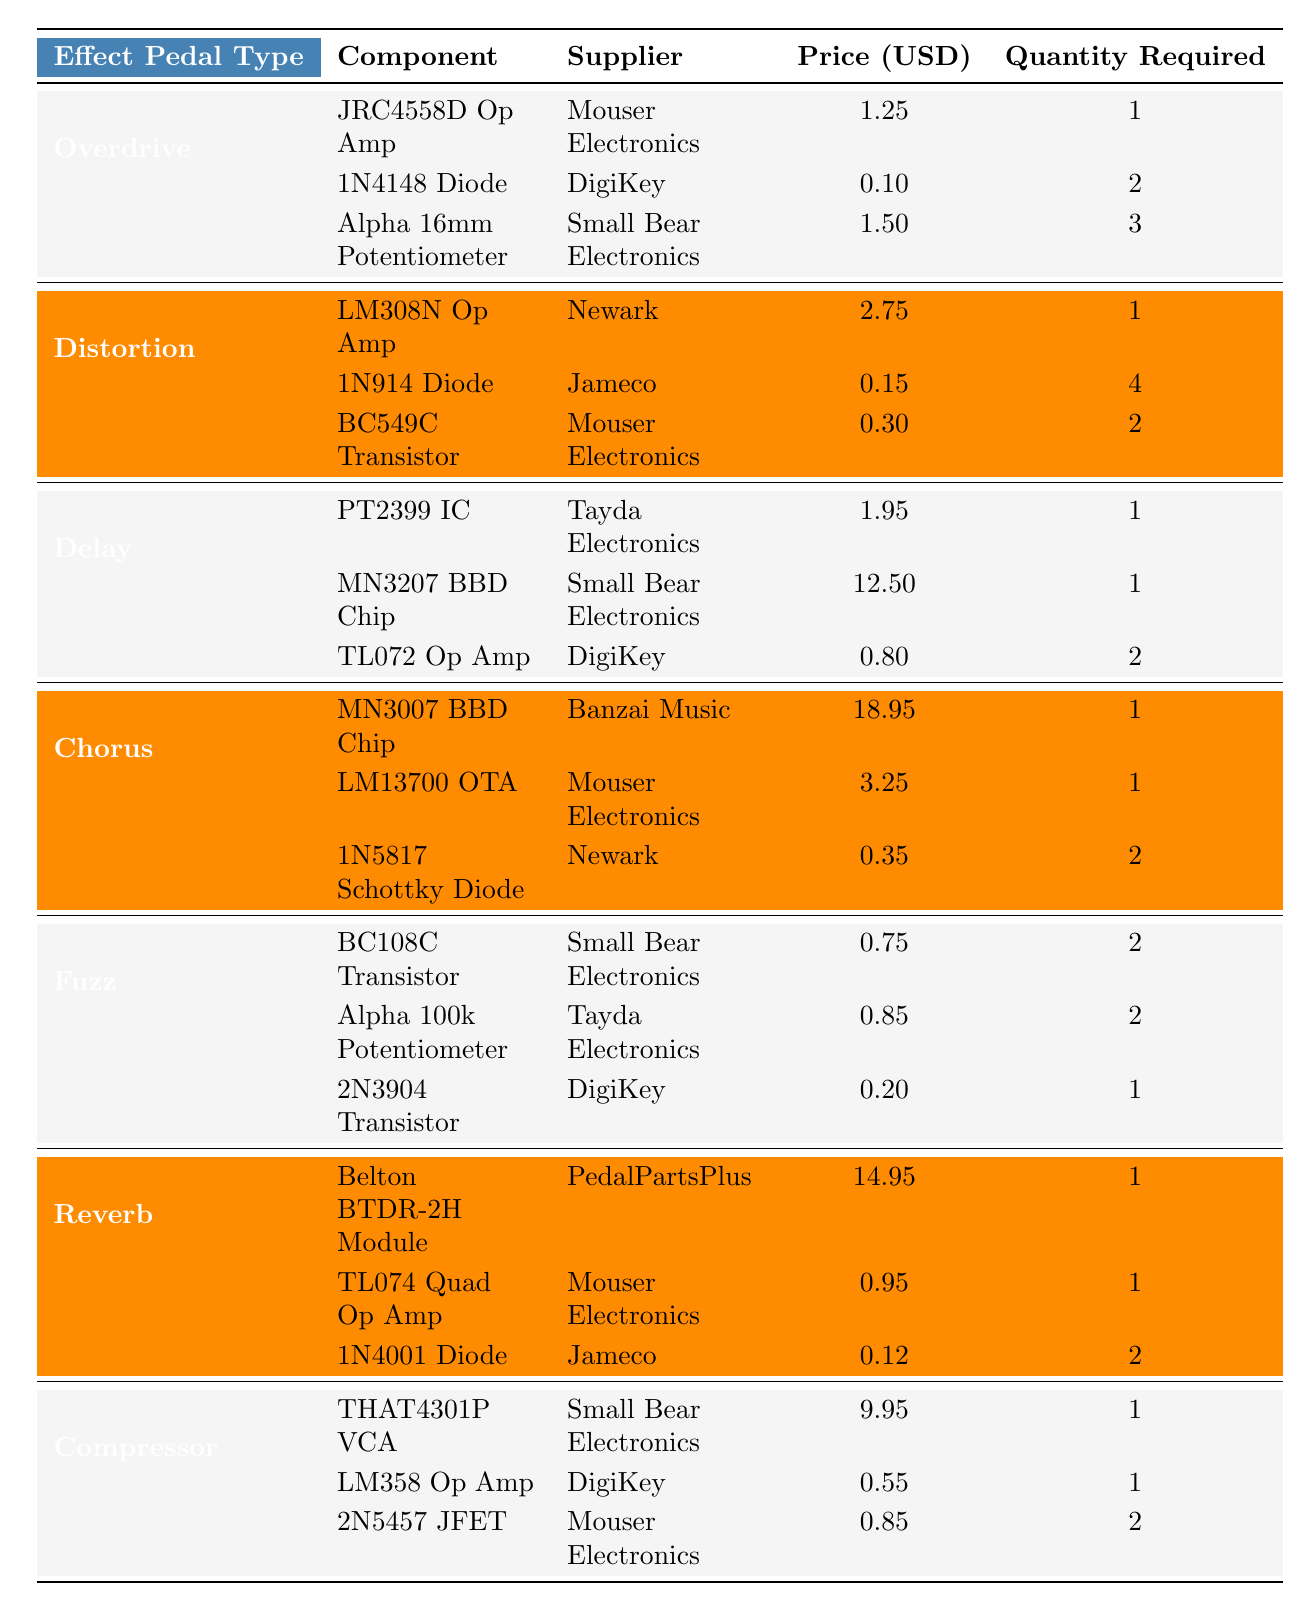What is the price of the JRC4558D Op Amp? The table lists the JRC4558D Op Amp under the Overdrive category, supplied by Mouser Electronics, and its price is 1.25 USD.
Answer: 1.25 USD How many 1N4148 Diodes are needed for the Overdrive pedal? Referring to the Overdrive section of the table, it shows that the 1N4148 Diode is needed in a quantity of 2.
Answer: 2 Which component for the Delay pedal is the most expensive? Looking at the Delay section, the MN3207 BBD Chip with a price of 12.50 USD is the most expensive component.
Answer: MN3207 BBD Chip What is the total cost of components needed for a Distortion pedal? To find the total, add the prices of each component: 2.75 + 0.15*4 + 0.30*2 = 2.75 + 0.60 + 0.60 = 4.95 USD.
Answer: 4.95 USD Is the Alpha 100k Potentiometer cheaper than the TL074 Quad Op Amp? The Alpha 100k Potentiometer costs 0.85 USD while the TL074 Quad Op Amp costs 0.95 USD, hence the Potentiometer is cheaper.
Answer: Yes What is the average price of the components for the Chorus pedal? The total price for Chorus components is 18.95 + 3.25 + 0.35 = 22.55 USD. There are 3 components, so the average is 22.55 / 3 = 7.52 USD.
Answer: 7.52 USD Which pedal type has the highest average component price? Calculate the averages: Overdrive: (1.25 + 0.10*2 + 1.50*3)/6 = 1.15; Distortion: (2.75 + 0.15*4 + 0.30*2)/6 = 0.68; Delay: (1.95 + 12.50 + 0.80*2)/6 = 2.61; Chorus: (18.95 + 3.25 + 0.35)/3 = 7.52; Fuzz: (0.75*2 + 0.85*2 + 0.20)/5 = 0.52; Reverb: (14.95 + 0.95 + 0.12*2)/5 = 3.05; Compressor: (9.95 + 0.55 + 0.85*2)/5 = 2.45. Chorus has the highest average at 7.52 USD.
Answer: Chorus What is the total quantity of all components required for the Fuzz pedal? Add the quantities: 2 + 2 + 1 = 5 components total for Fuzz pedal.
Answer: 5 Are there any components from Small Bear Electronics used in the Reverb pedal? The Reverb section lists components and shows only the TL074 Quad Op Amp and 1N4001 Diode from other suppliers, hence there are no components from Small Bear Electronics in Reverb.
Answer: No 